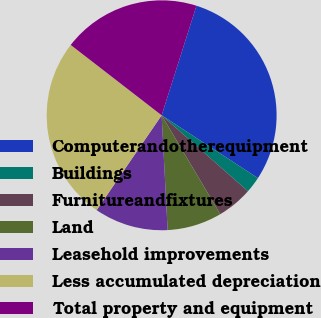Convert chart. <chart><loc_0><loc_0><loc_500><loc_500><pie_chart><fcel>Computerandotherequipment<fcel>Buildings<fcel>Furnitureandfixtures<fcel>Land<fcel>Leasehold improvements<fcel>Less accumulated depreciation<fcel>Total property and equipment<nl><fcel>29.3%<fcel>2.29%<fcel>4.99%<fcel>7.69%<fcel>10.39%<fcel>25.92%<fcel>19.42%<nl></chart> 